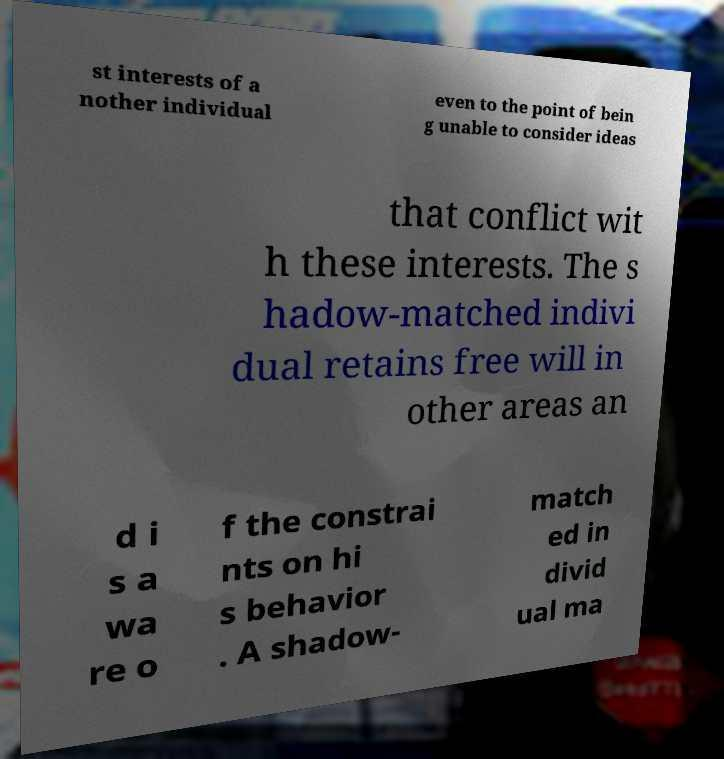Could you extract and type out the text from this image? st interests of a nother individual even to the point of bein g unable to consider ideas that conflict wit h these interests. The s hadow-matched indivi dual retains free will in other areas an d i s a wa re o f the constrai nts on hi s behavior . A shadow- match ed in divid ual ma 